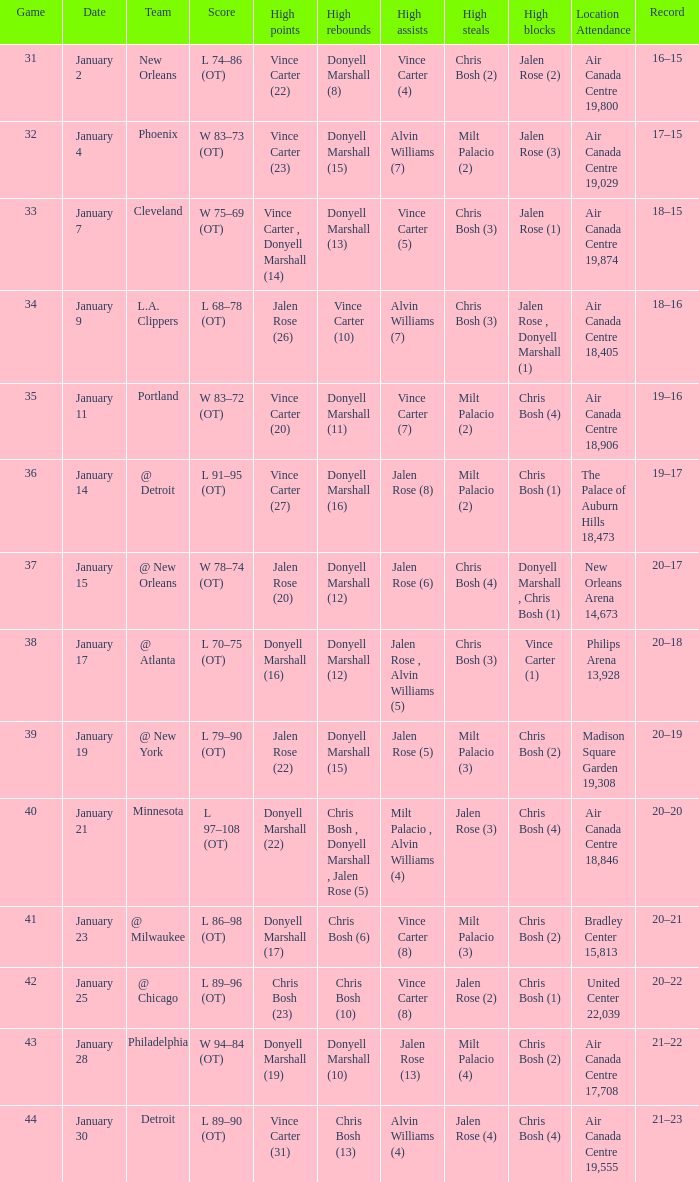What is the Location and Attendance with a Record of 21–22? Air Canada Centre 17,708. 